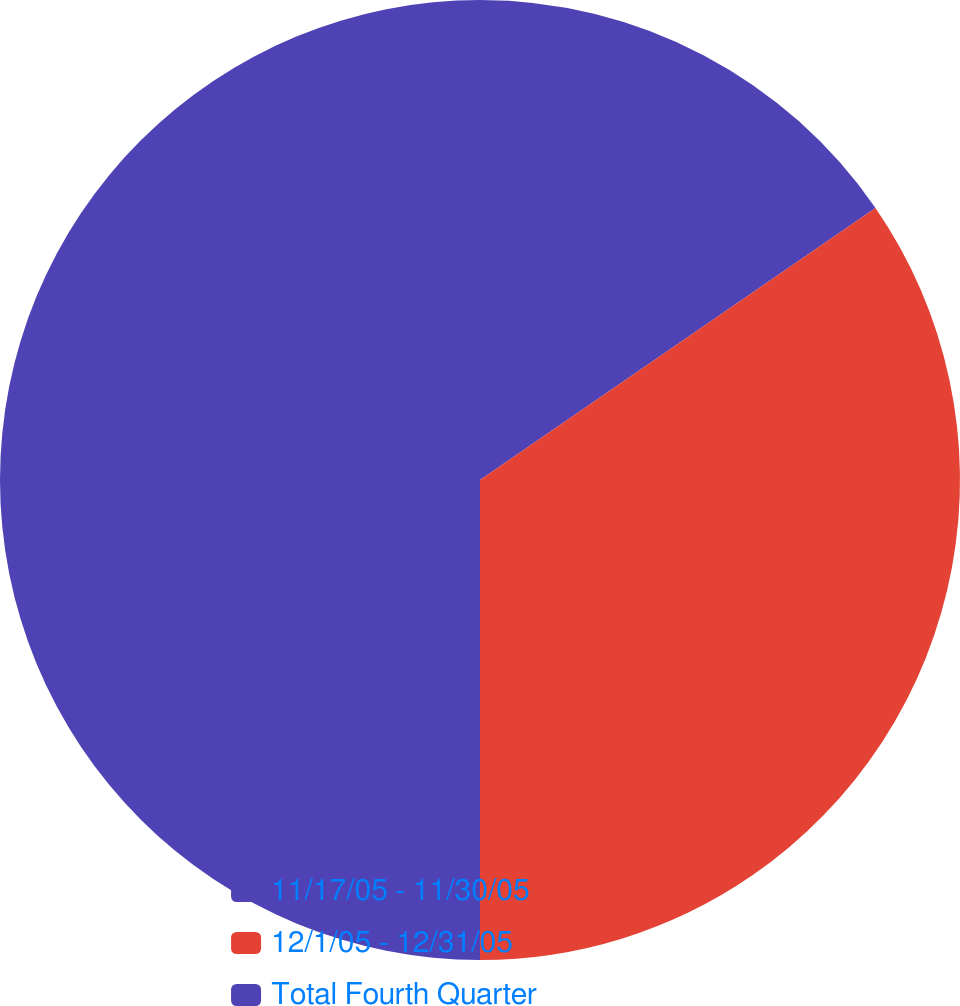<chart> <loc_0><loc_0><loc_500><loc_500><pie_chart><fcel>11/17/05 - 11/30/05<fcel>12/1/05 - 12/31/05<fcel>Total Fourth Quarter<nl><fcel>15.41%<fcel>34.59%<fcel>50.0%<nl></chart> 